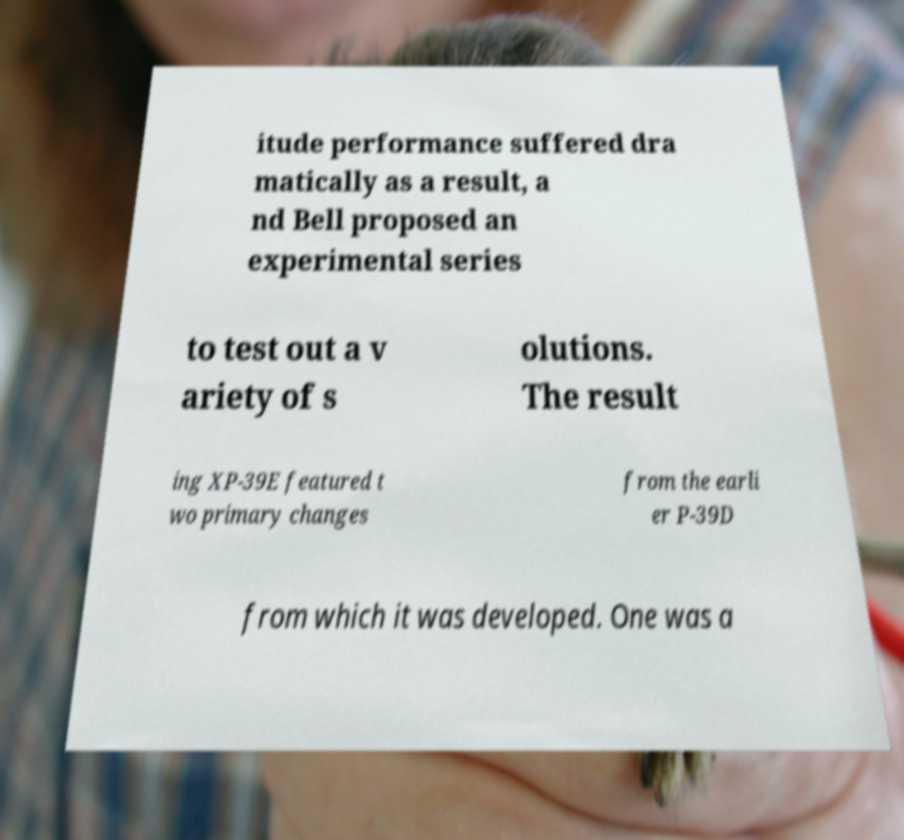Could you assist in decoding the text presented in this image and type it out clearly? itude performance suffered dra matically as a result, a nd Bell proposed an experimental series to test out a v ariety of s olutions. The result ing XP-39E featured t wo primary changes from the earli er P-39D from which it was developed. One was a 